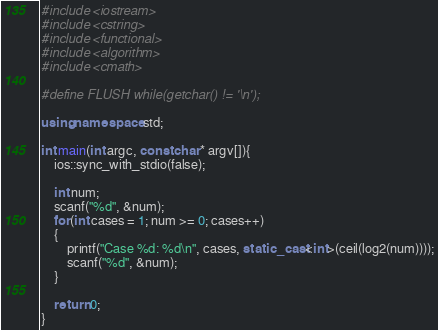Convert code to text. <code><loc_0><loc_0><loc_500><loc_500><_C++_>#include <iostream>
#include <cstring>
#include <functional>
#include <algorithm>
#include <cmath>

#define FLUSH while(getchar() != '\n');

using namespace std;

int main(int argc, const char* argv[]){
    ios::sync_with_stdio(false);

    int num;
    scanf("%d", &num);
    for(int cases = 1; num >= 0; cases++)
    {
        printf("Case %d: %d\n", cases, static_cast<int>(ceil(log2(num))));
        scanf("%d", &num);
    }

    return 0;
}
</code> 